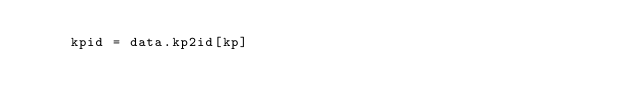<code> <loc_0><loc_0><loc_500><loc_500><_Python_>    kpid = data.kp2id[kp]</code> 